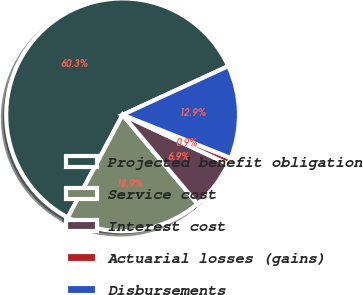<chart> <loc_0><loc_0><loc_500><loc_500><pie_chart><fcel>Projected benefit obligation<fcel>Service cost<fcel>Interest cost<fcel>Actuarial losses (gains)<fcel>Disbursements<nl><fcel>60.33%<fcel>18.93%<fcel>6.91%<fcel>0.91%<fcel>12.92%<nl></chart> 